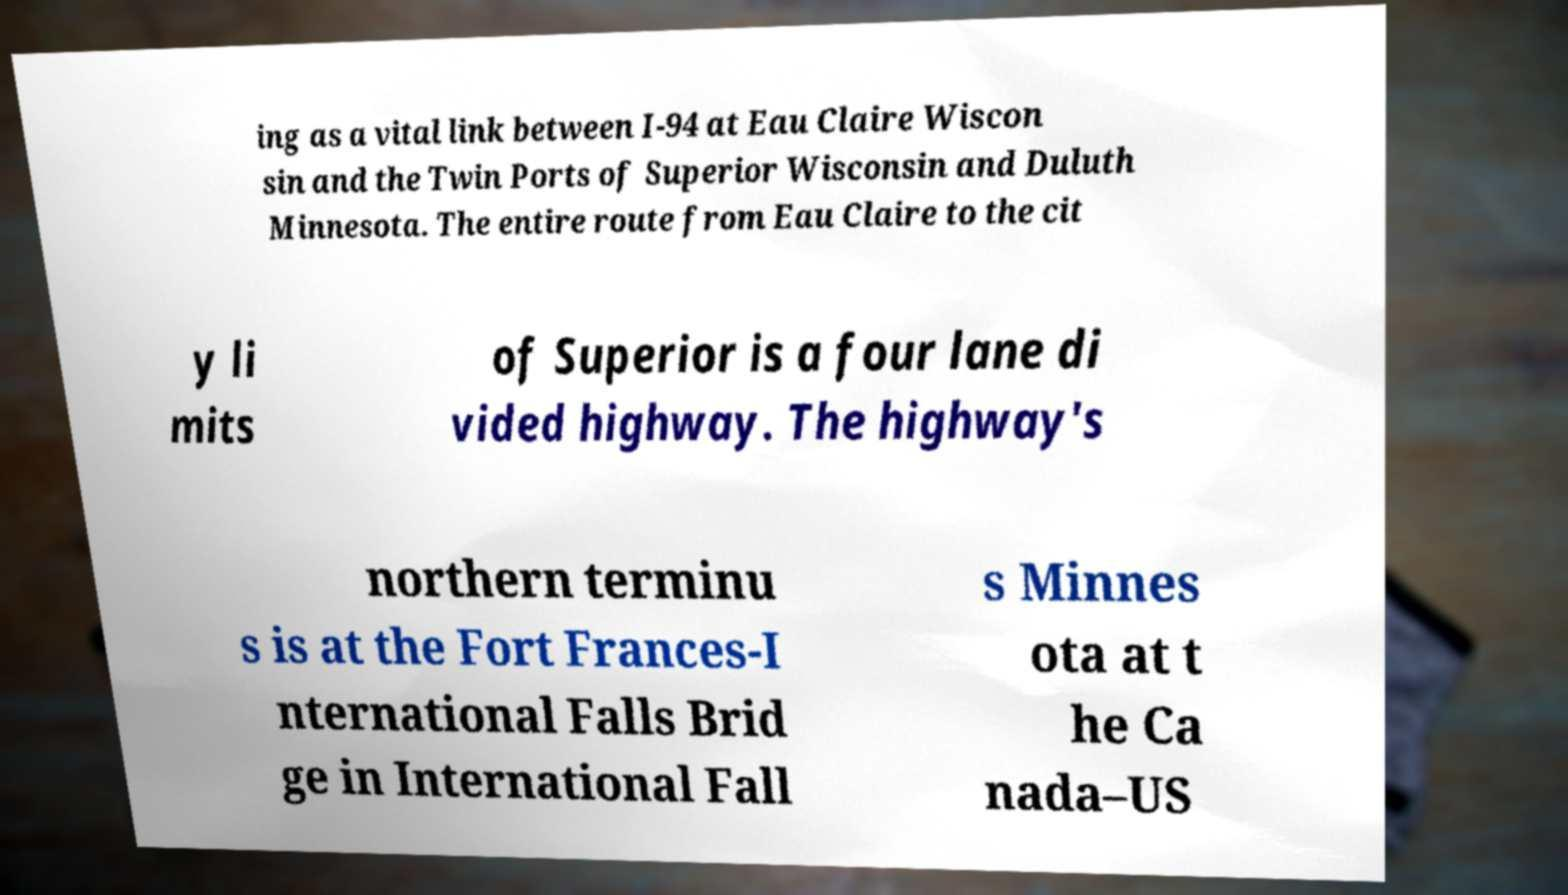There's text embedded in this image that I need extracted. Can you transcribe it verbatim? ing as a vital link between I-94 at Eau Claire Wiscon sin and the Twin Ports of Superior Wisconsin and Duluth Minnesota. The entire route from Eau Claire to the cit y li mits of Superior is a four lane di vided highway. The highway's northern terminu s is at the Fort Frances-I nternational Falls Brid ge in International Fall s Minnes ota at t he Ca nada–US 